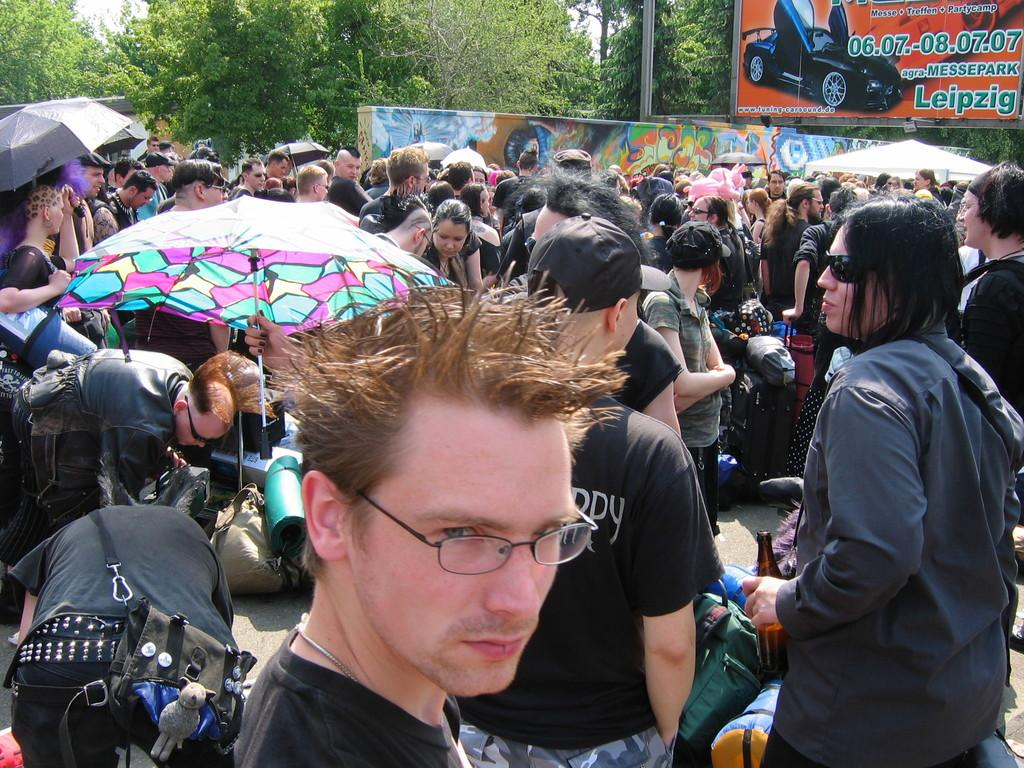How many people are in the group visible in the image? There is a group of people in the image, but the exact number is not specified. What are the people holding in the image? Umbrellas are visible in the image, which suggests that the people might be holding them. What items can be seen besides the umbrellas? Bags are present in the image, along with a hoarding, a tent, a wall, a pole, trees, and the sky. What is the background of the image? The background of the image includes trees and the sky. What type of cherry is being used as a decoration on the queen's eye in the image? There is no queen, cherry, or eye present in the image. 